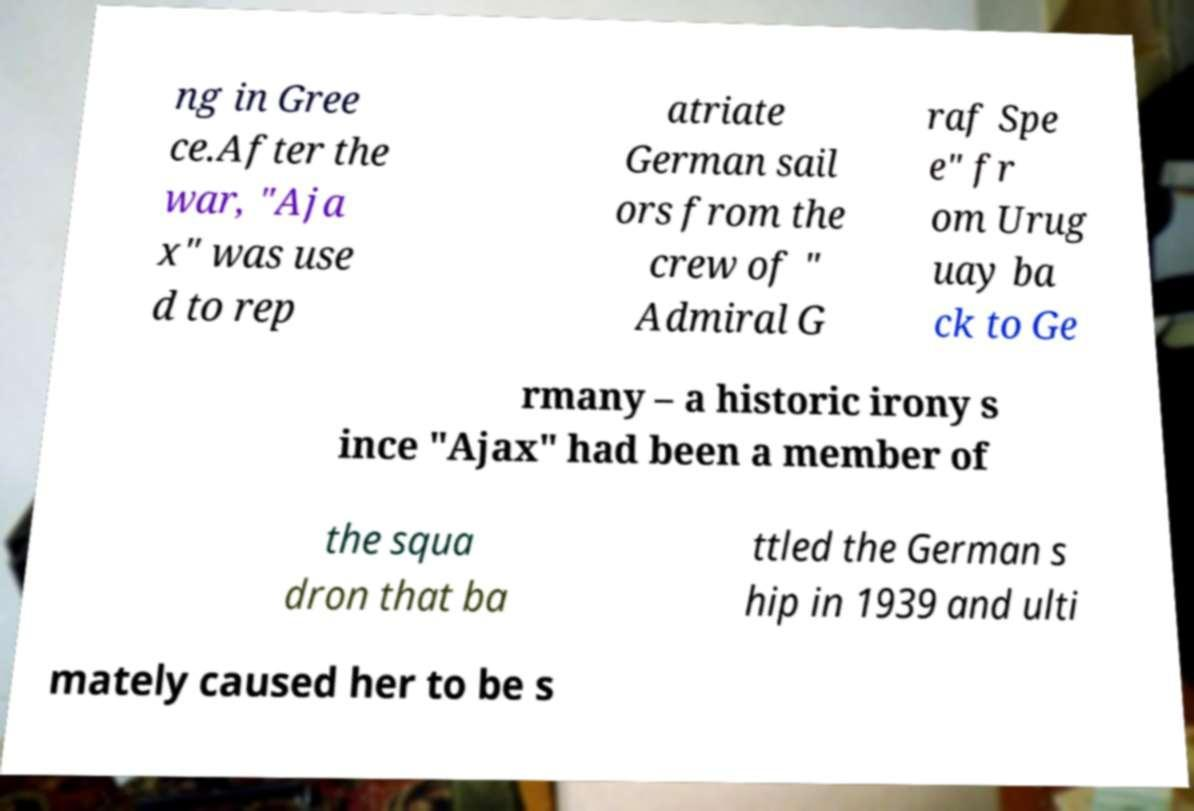Could you extract and type out the text from this image? ng in Gree ce.After the war, "Aja x" was use d to rep atriate German sail ors from the crew of " Admiral G raf Spe e" fr om Urug uay ba ck to Ge rmany – a historic irony s ince "Ajax" had been a member of the squa dron that ba ttled the German s hip in 1939 and ulti mately caused her to be s 